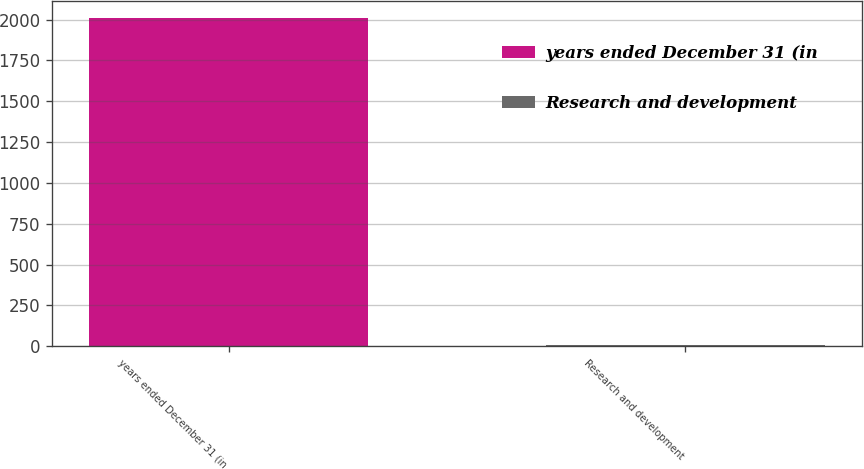Convert chart. <chart><loc_0><loc_0><loc_500><loc_500><bar_chart><fcel>years ended December 31 (in<fcel>Research and development<nl><fcel>2011<fcel>5<nl></chart> 